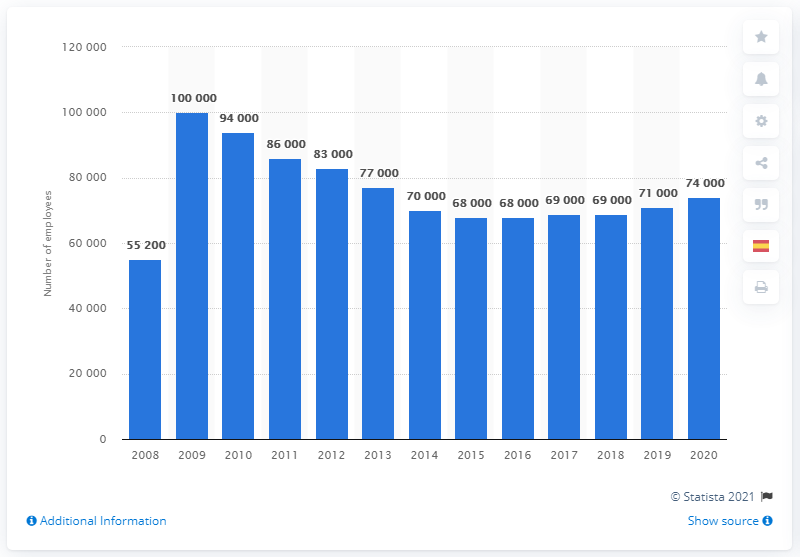Point out several critical features in this image. In 2009, Merck & Co. had approximately 100,000 employees. In the year 2009, Merck & Co. had the largest number of employees. In 2020, Merck had approximately 74,000 full-time employees. 